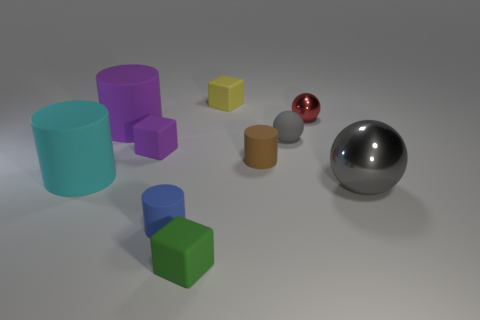How many gray spheres must be subtracted to get 1 gray spheres? 1 Subtract all small brown rubber cylinders. How many cylinders are left? 3 Subtract all purple cylinders. How many gray spheres are left? 2 Subtract 2 blocks. How many blocks are left? 1 Subtract all red spheres. How many spheres are left? 2 Subtract all blocks. How many objects are left? 7 Add 6 cubes. How many cubes are left? 9 Add 5 large gray metallic cylinders. How many large gray metallic cylinders exist? 5 Subtract 0 green balls. How many objects are left? 10 Subtract all red cubes. Subtract all red balls. How many cubes are left? 3 